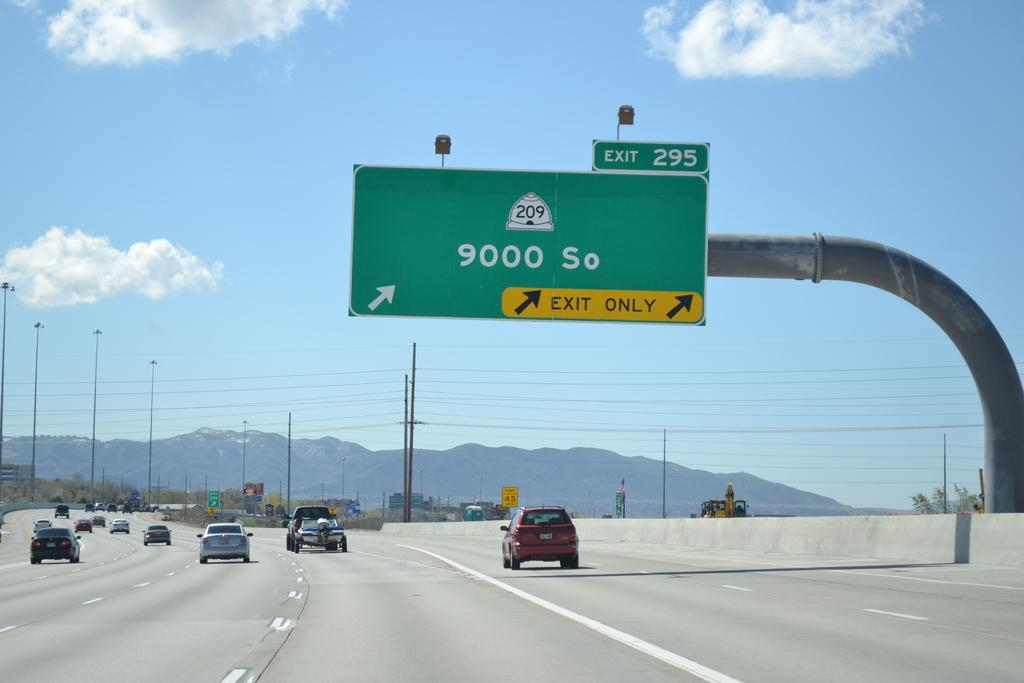<image>
Render a clear and concise summary of the photo. the number 9000 So that is on a sign 